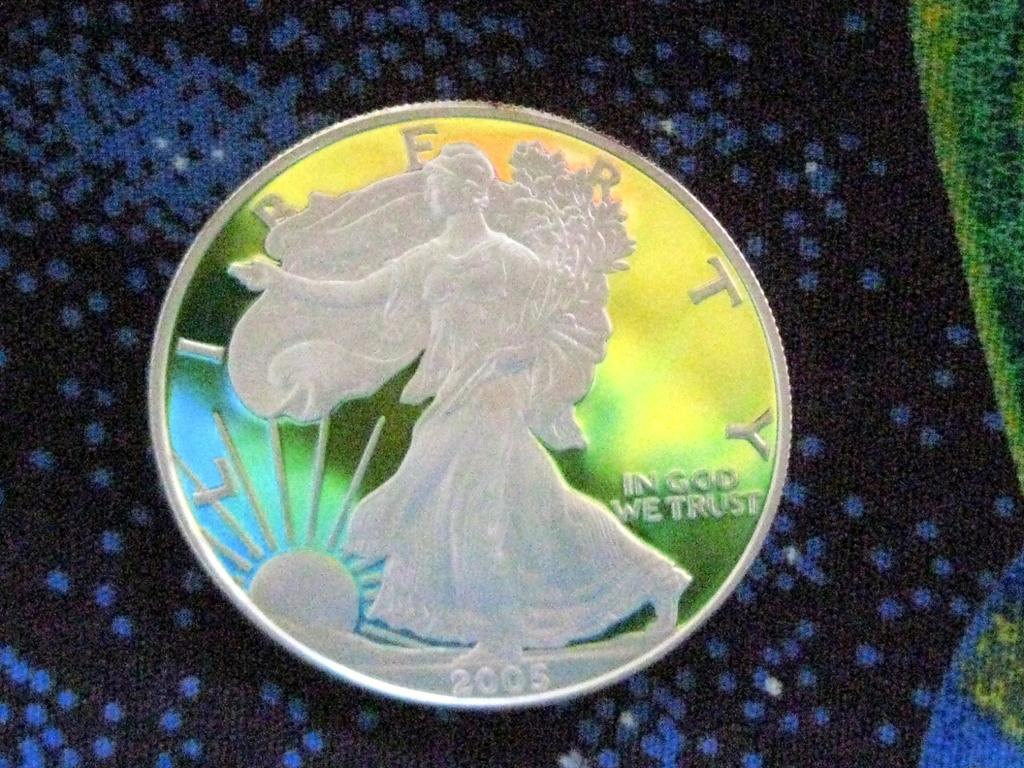<image>
Write a terse but informative summary of the picture. A 2005 quarter that says liberty and in god we trust. 